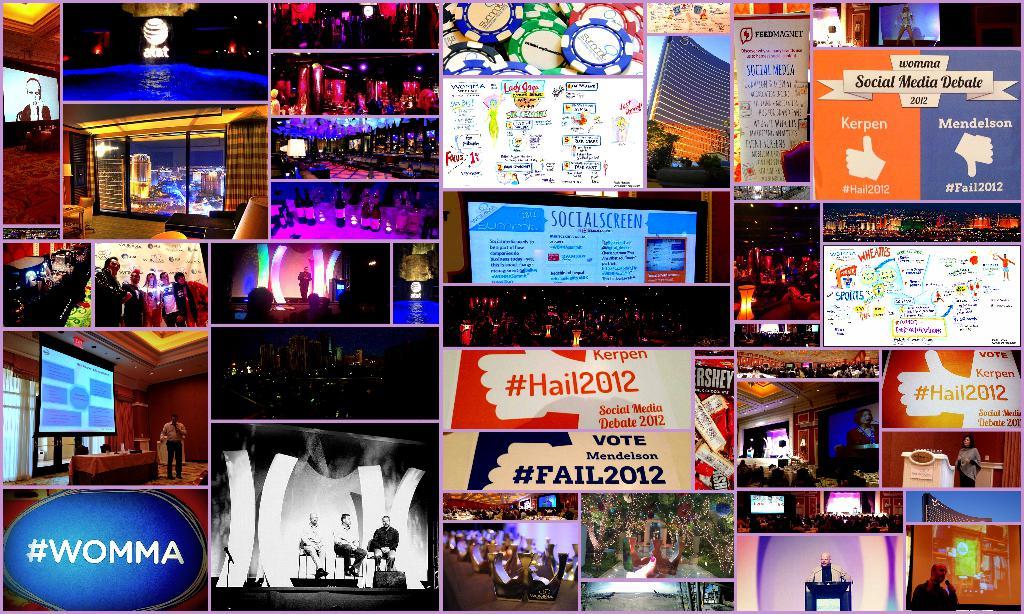What year is the social media debate?
Offer a very short reply. 2012. 